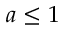<formula> <loc_0><loc_0><loc_500><loc_500>a \leq 1</formula> 